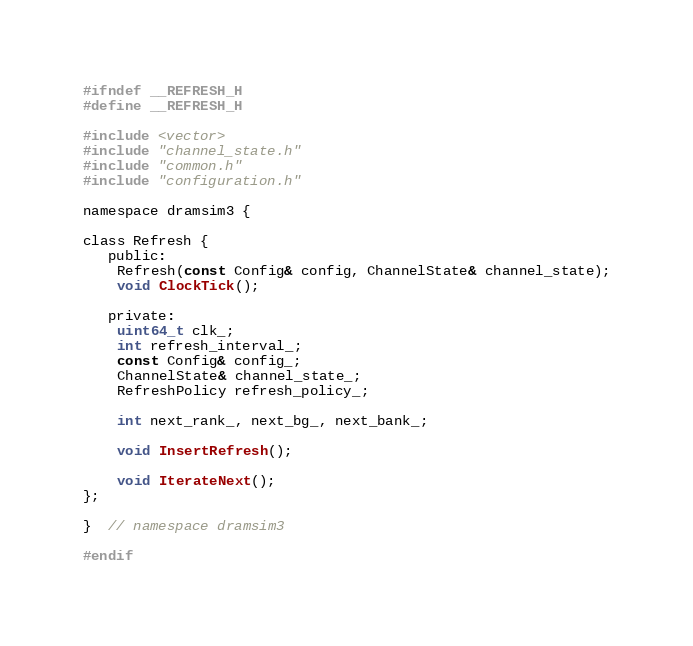Convert code to text. <code><loc_0><loc_0><loc_500><loc_500><_C_>#ifndef __REFRESH_H
#define __REFRESH_H

#include <vector>
#include "channel_state.h"
#include "common.h"
#include "configuration.h"

namespace dramsim3 {

class Refresh {
   public:
    Refresh(const Config& config, ChannelState& channel_state);
    void ClockTick();

   private:
    uint64_t clk_;
    int refresh_interval_;
    const Config& config_;
    ChannelState& channel_state_;
    RefreshPolicy refresh_policy_;

    int next_rank_, next_bg_, next_bank_;

    void InsertRefresh();

    void IterateNext();
};

}  // namespace dramsim3

#endif</code> 